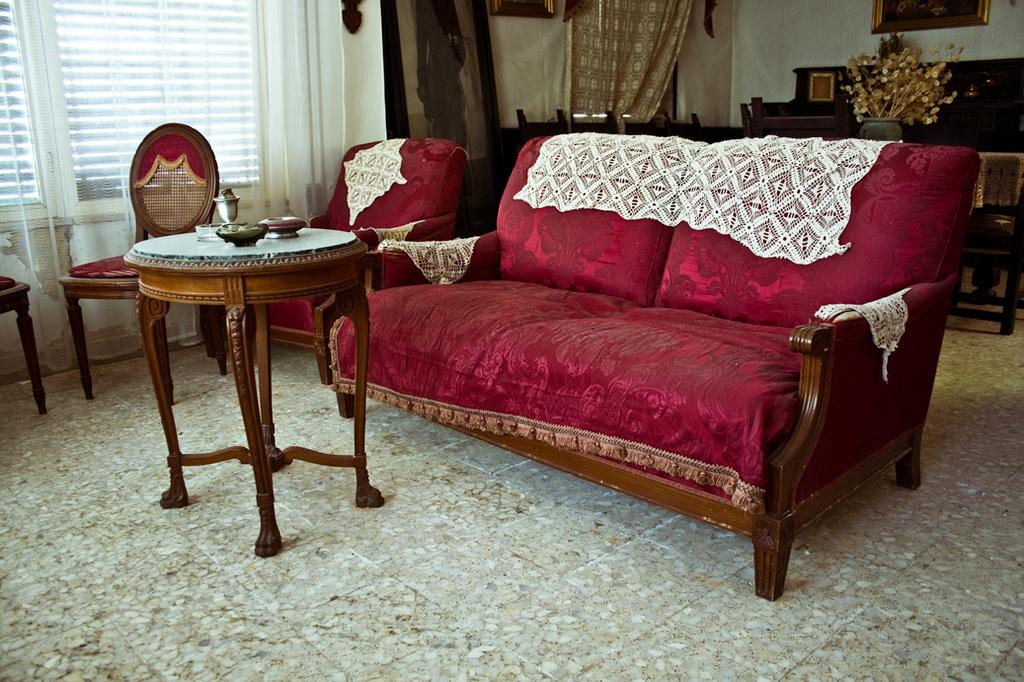What is located in the center of the image? There is a sofa and a stool in the center of the image. What can be seen in the background of the image? There are chairs, a window, a curtain, a photo frame, and a wall in the background of the image. What is associated with the window in the image? There is a curtain associated with the window in the image. What type of chin can be seen in the image? There is no chin present in the image. Is there a note attached to the photo frame in the image? There is no mention of a note in the image, so it cannot be determined if one is attached to the photo frame. 